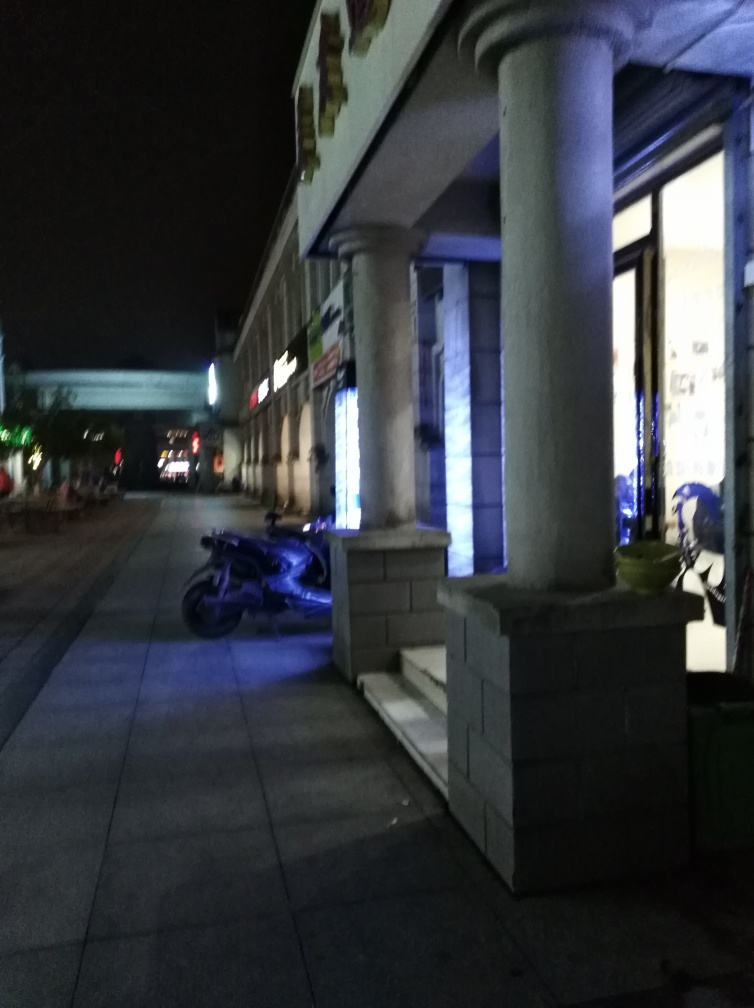What elements in this image hint at the location or setting? The architectural style of the building, with its classic columns and the commercial signage, hint at an urban setting, possibly a street lined with shops or a commercial area. The presence of the motorcycle parked on the sidewalk could indicate this is a place where locals frequent, and the wide sidewalk suggests a pedestrian-friendly area. Is there anything in the picture that indicates movement or stillness? The image conveys a sense of stillness. The parked motorcycle and the absence of people suggest a lack of movement. Additionally, the stationary reflections of light on the ground and the calmness of the environment contribute to the static feeling of the scene. 